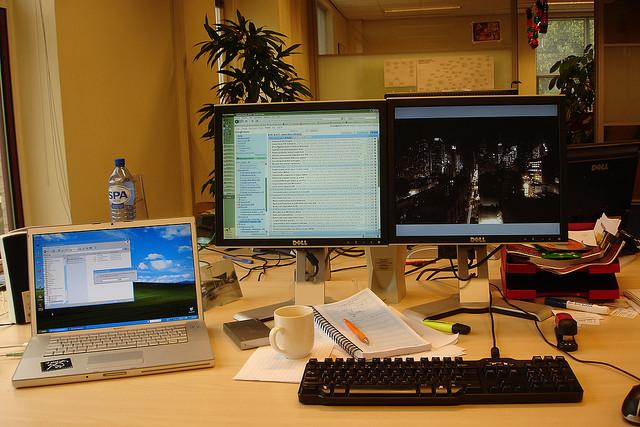Is one computer running the two stand alone monitors at the same time?
Write a very short answer. Yes. Has anything been consumed from the bottle?
Be succinct. No. Is this a home office?
Be succinct. Yes. What Operating System is the Compaq laptop running?
Keep it brief. Windows. Is the object on the paper a pencil?
Keep it brief. No. 